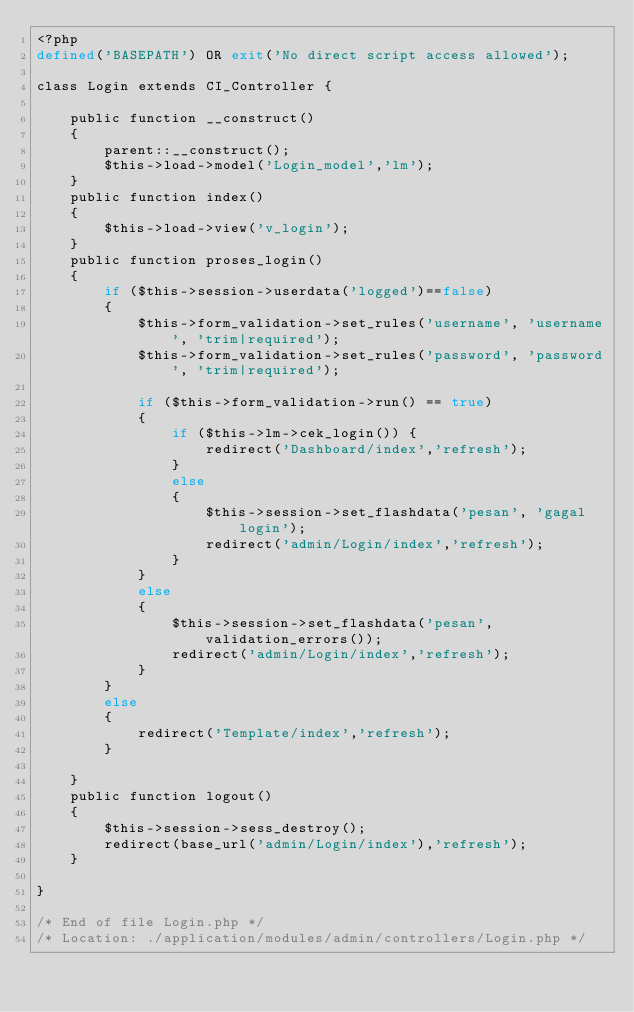<code> <loc_0><loc_0><loc_500><loc_500><_PHP_><?php
defined('BASEPATH') OR exit('No direct script access allowed');

class Login extends CI_Controller {

	public function __construct()
	{
		parent::__construct();
		$this->load->model('Login_model','lm');
	}
	public function index()
	{
		$this->load->view('v_login');		
	}
	public function proses_login()
	{
		if ($this->session->userdata('logged')==false) 
		{
			$this->form_validation->set_rules('username', 'username', 'trim|required');
			$this->form_validation->set_rules('password', 'password', 'trim|required');

			if ($this->form_validation->run() == true) 
			{
				if ($this->lm->cek_login()) {
					redirect('Dashboard/index','refresh');
				}
				else
				{
					$this->session->set_flashdata('pesan', 'gagal login');
					redirect('admin/Login/index','refresh');
				}
			} 
			else 
			{
				$this->session->set_flashdata('pesan',validation_errors());
				redirect('admin/Login/index','refresh');
			}
		}
		else
		{
			redirect('Template/index','refresh');
		}
		
	}
	public function logout()
	{
		$this->session->sess_destroy();
		redirect(base_url('admin/Login/index'),'refresh');
	}

}

/* End of file Login.php */
/* Location: ./application/modules/admin/controllers/Login.php */</code> 